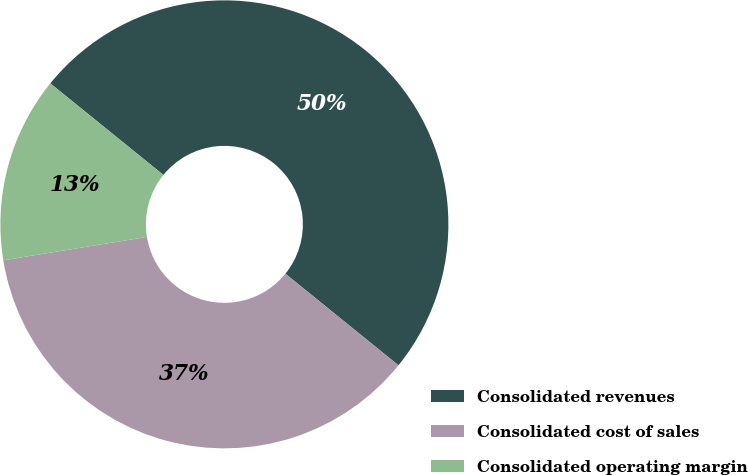<chart> <loc_0><loc_0><loc_500><loc_500><pie_chart><fcel>Consolidated revenues<fcel>Consolidated cost of sales<fcel>Consolidated operating margin<nl><fcel>50.0%<fcel>36.6%<fcel>13.4%<nl></chart> 